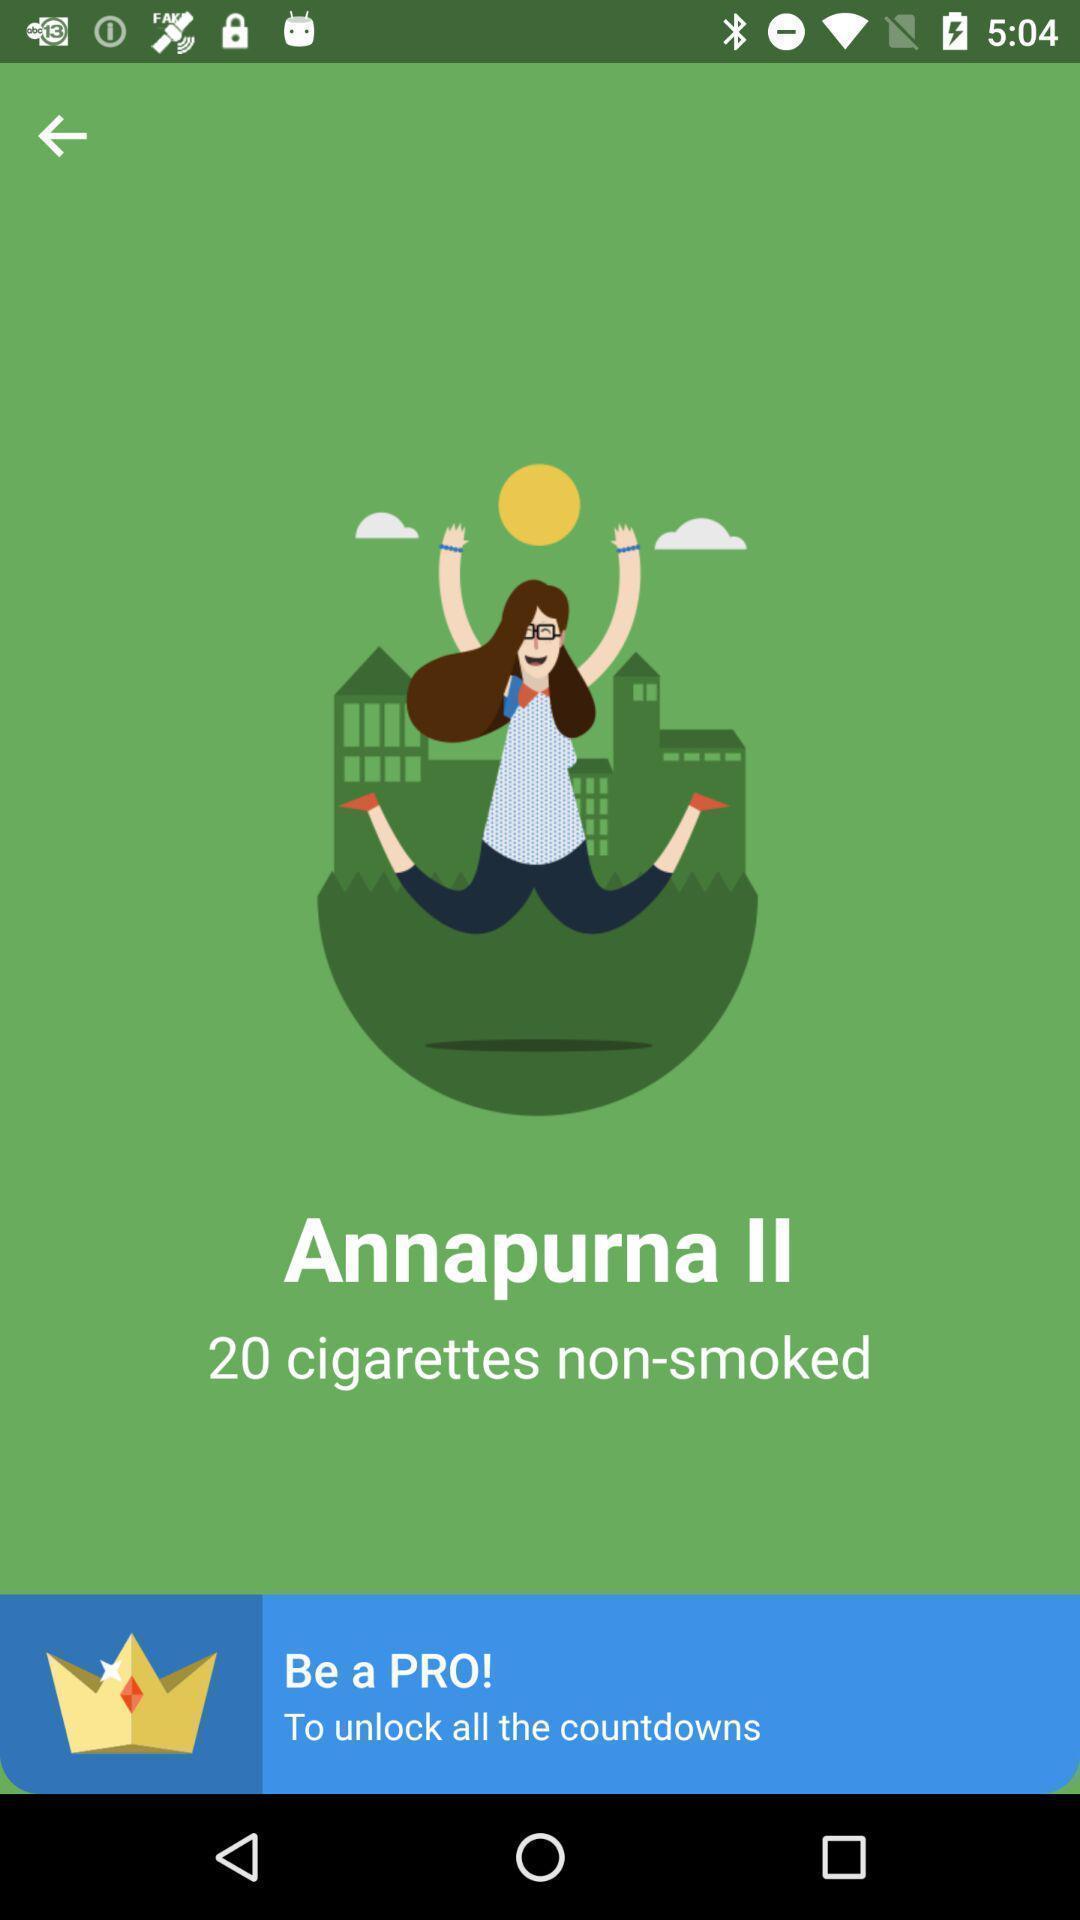Summarize the information in this screenshot. Welcome page of social app. 